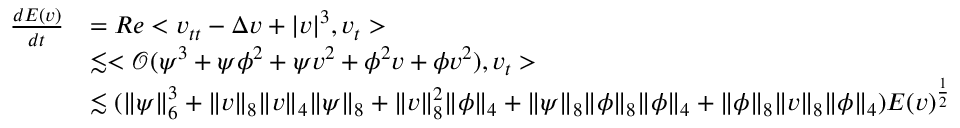<formula> <loc_0><loc_0><loc_500><loc_500>\begin{array} { r l } { \frac { d E ( v ) } { d t } } & { = R e < v _ { t t } - \Delta v + | v | ^ { 3 } , v _ { t } > } \\ & { \lesssim < \mathcal { O } ( \psi ^ { 3 } + \psi \phi ^ { 2 } + \psi v ^ { 2 } + \phi ^ { 2 } v + \phi v ^ { 2 } ) , v _ { t } > } \\ & { \lesssim ( \| \psi \| _ { 6 } ^ { 3 } + \| v \| _ { 8 } \| v \| _ { 4 } \| \psi \| _ { 8 } + \| v \| _ { 8 } ^ { 2 } \| \phi \| _ { 4 } + \| \psi \| _ { 8 } \| \phi \| _ { 8 } \| \phi \| _ { 4 } + \| \phi \| _ { 8 } \| v \| _ { 8 } \| \phi \| _ { 4 } ) E ( v ) ^ { \frac { 1 } { 2 } } } \end{array}</formula> 